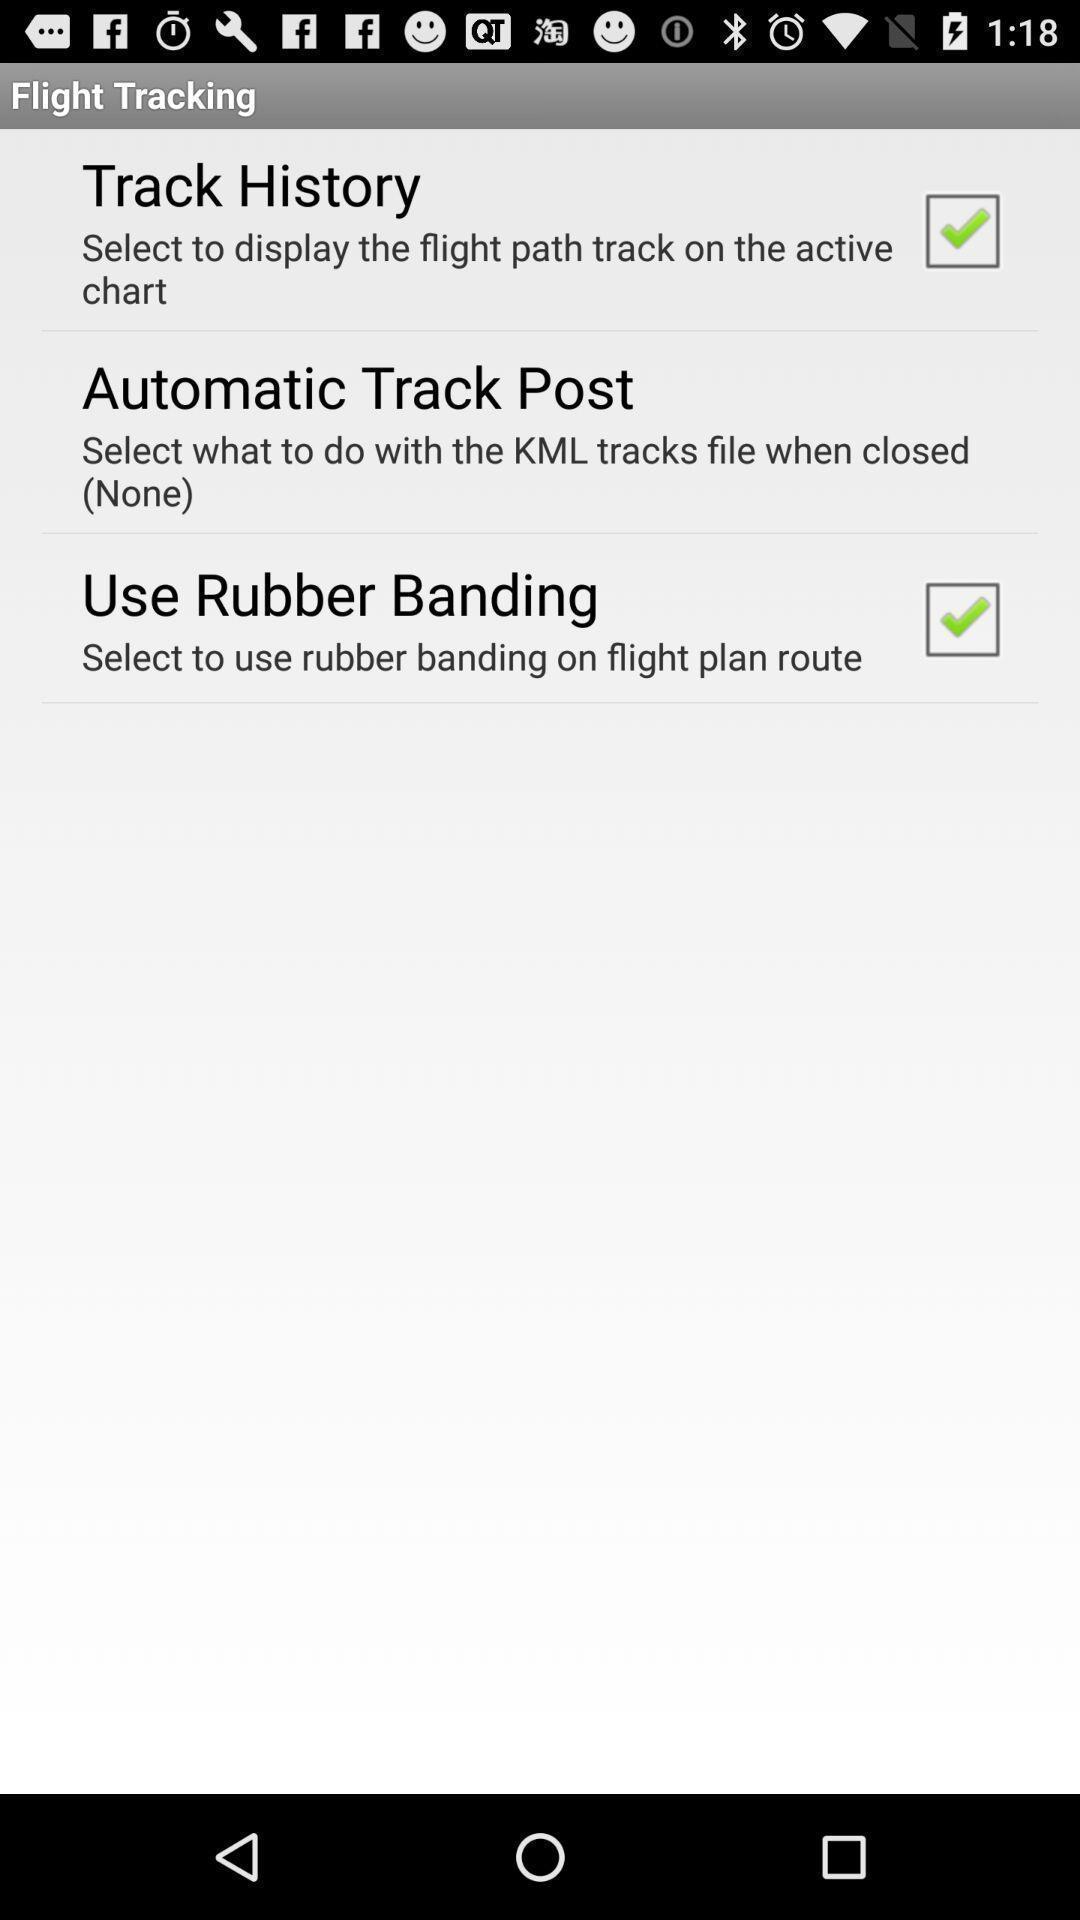Tell me about the visual elements in this screen capture. Settings page displaying. 